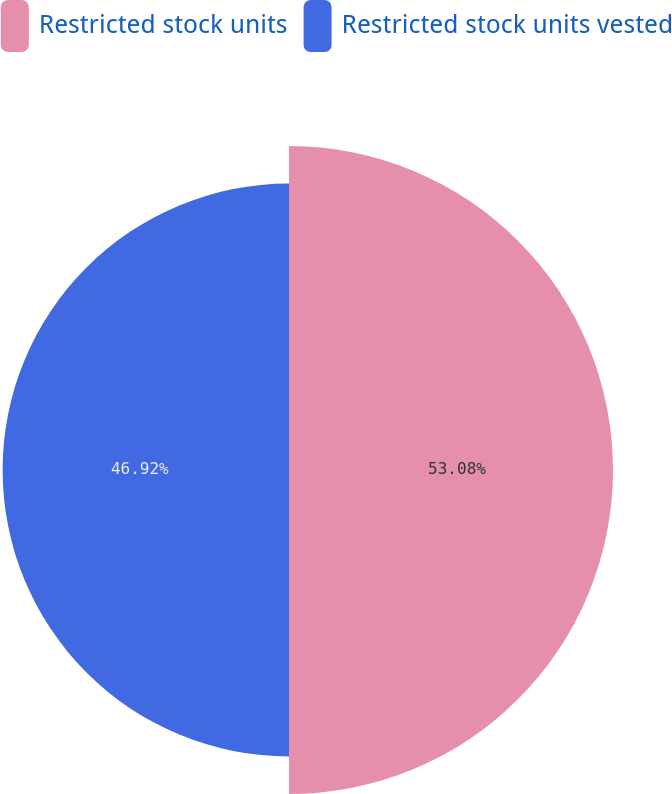Convert chart. <chart><loc_0><loc_0><loc_500><loc_500><pie_chart><fcel>Restricted stock units<fcel>Restricted stock units vested<nl><fcel>53.08%<fcel>46.92%<nl></chart> 